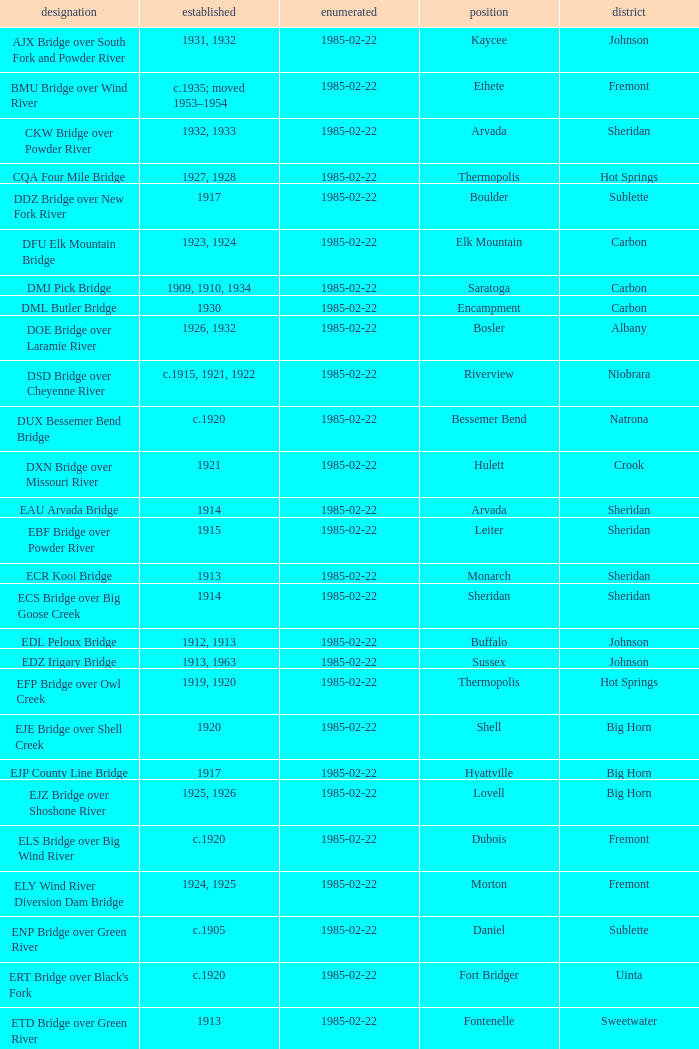What is the bridge at daniel in sublette county listed as? 1985-02-22. 